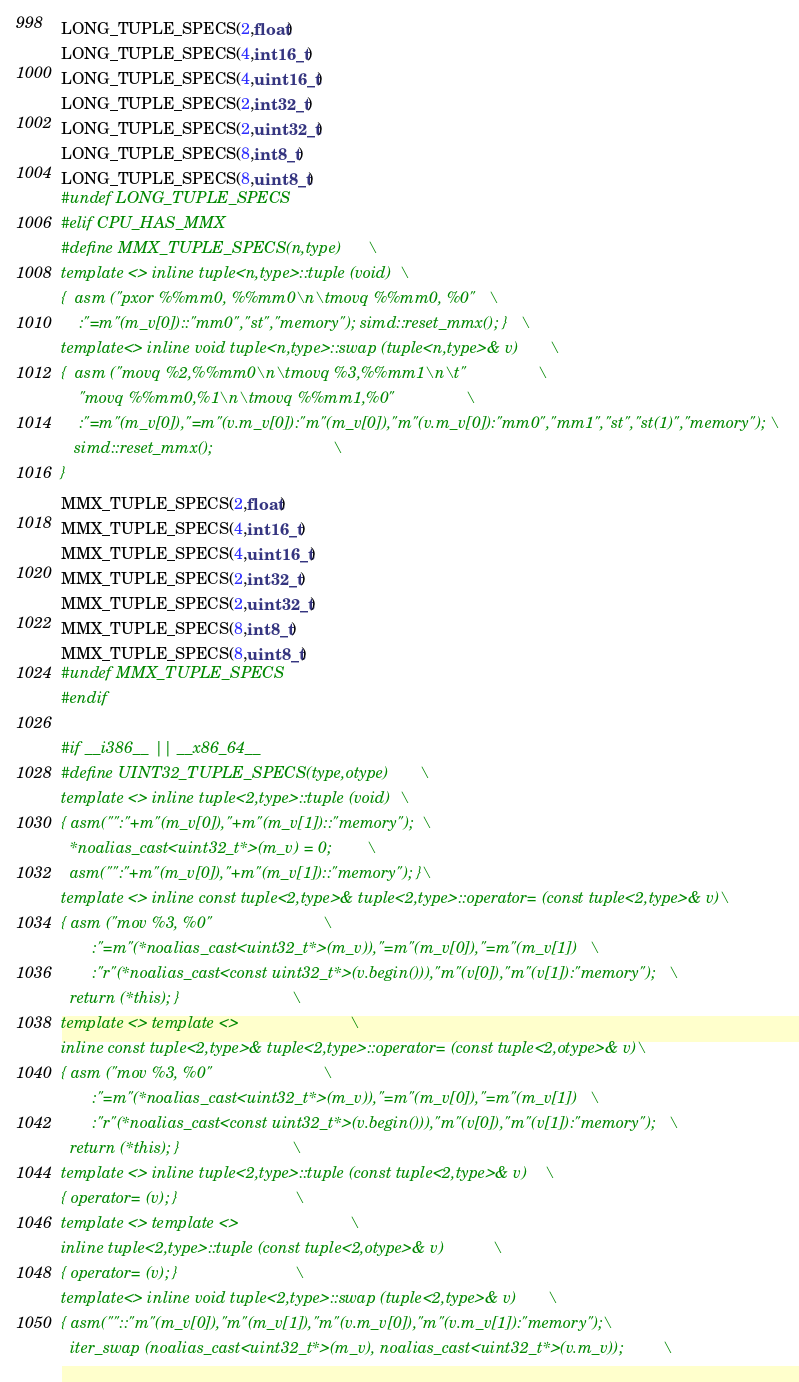Convert code to text. <code><loc_0><loc_0><loc_500><loc_500><_C_>LONG_TUPLE_SPECS(2,float)
LONG_TUPLE_SPECS(4,int16_t)
LONG_TUPLE_SPECS(4,uint16_t)
LONG_TUPLE_SPECS(2,int32_t)
LONG_TUPLE_SPECS(2,uint32_t)
LONG_TUPLE_SPECS(8,int8_t)
LONG_TUPLE_SPECS(8,uint8_t)
#undef LONG_TUPLE_SPECS
#elif CPU_HAS_MMX
#define MMX_TUPLE_SPECS(n,type)		\
template <> inline tuple<n,type>::tuple (void)	\
{  asm ("pxor %%mm0, %%mm0\n\tmovq %%mm0, %0"	\
	:"=m"(m_v[0])::"mm0","st","memory"); simd::reset_mmx(); }	\
template<> inline void tuple<n,type>::swap (tuple<n,type>& v)		\
{  asm ("movq %2,%%mm0\n\tmovq %3,%%mm1\n\t"				\
	"movq %%mm0,%1\n\tmovq %%mm1,%0"				\
	:"=m"(m_v[0]),"=m"(v.m_v[0]):"m"(m_v[0]),"m"(v.m_v[0]):"mm0","mm1","st","st(1)","memory"); \
   simd::reset_mmx();							\
}
MMX_TUPLE_SPECS(2,float)
MMX_TUPLE_SPECS(4,int16_t)
MMX_TUPLE_SPECS(4,uint16_t)
MMX_TUPLE_SPECS(2,int32_t)
MMX_TUPLE_SPECS(2,uint32_t)
MMX_TUPLE_SPECS(8,int8_t)
MMX_TUPLE_SPECS(8,uint8_t)
#undef MMX_TUPLE_SPECS
#endif

#if __i386__ || __x86_64__
#define UINT32_TUPLE_SPECS(type,otype)		\
template <> inline tuple<2,type>::tuple (void)	\
{ asm("":"+m"(m_v[0]),"+m"(m_v[1])::"memory");	\
  *noalias_cast<uint32_t*>(m_v) = 0;		\
  asm("":"+m"(m_v[0]),"+m"(m_v[1])::"memory"); }\
template <> inline const tuple<2,type>& tuple<2,type>::operator= (const tuple<2,type>& v)\
{ asm ("mov %3, %0"							\
       :"=m"(*noalias_cast<uint32_t*>(m_v)),"=m"(m_v[0]),"=m"(m_v[1])	\
       :"r"(*noalias_cast<const uint32_t*>(v.begin())),"m"(v[0]),"m"(v[1]):"memory");	\
  return (*this); }							\
template <> template <>							\
inline const tuple<2,type>& tuple<2,type>::operator= (const tuple<2,otype>& v)\
{ asm ("mov %3, %0"							\
       :"=m"(*noalias_cast<uint32_t*>(m_v)),"=m"(m_v[0]),"=m"(m_v[1])	\
       :"r"(*noalias_cast<const uint32_t*>(v.begin())),"m"(v[0]),"m"(v[1]):"memory");	\
  return (*this); }							\
template <> inline tuple<2,type>::tuple (const tuple<2,type>& v)	\
{ operator= (v); }							\
template <> template <>							\
inline tuple<2,type>::tuple (const tuple<2,otype>& v)			\
{ operator= (v); }							\
template<> inline void tuple<2,type>::swap (tuple<2,type>& v)		\
{ asm(""::"m"(m_v[0]),"m"(m_v[1]),"m"(v.m_v[0]),"m"(v.m_v[1]):"memory");\
  iter_swap (noalias_cast<uint32_t*>(m_v), noalias_cast<uint32_t*>(v.m_v));			\</code> 